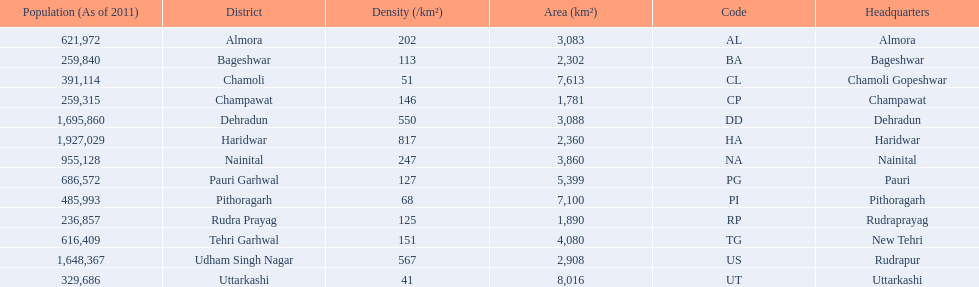What are all the districts? Almora, Bageshwar, Chamoli, Champawat, Dehradun, Haridwar, Nainital, Pauri Garhwal, Pithoragarh, Rudra Prayag, Tehri Garhwal, Udham Singh Nagar, Uttarkashi. And their densities? 202, 113, 51, 146, 550, 817, 247, 127, 68, 125, 151, 567, 41. Would you be able to parse every entry in this table? {'header': ['Population (As of 2011)', 'District', 'Density (/km²)', 'Area (km²)', 'Code', 'Headquarters'], 'rows': [['621,972', 'Almora', '202', '3,083', 'AL', 'Almora'], ['259,840', 'Bageshwar', '113', '2,302', 'BA', 'Bageshwar'], ['391,114', 'Chamoli', '51', '7,613', 'CL', 'Chamoli Gopeshwar'], ['259,315', 'Champawat', '146', '1,781', 'CP', 'Champawat'], ['1,695,860', 'Dehradun', '550', '3,088', 'DD', 'Dehradun'], ['1,927,029', 'Haridwar', '817', '2,360', 'HA', 'Haridwar'], ['955,128', 'Nainital', '247', '3,860', 'NA', 'Nainital'], ['686,572', 'Pauri Garhwal', '127', '5,399', 'PG', 'Pauri'], ['485,993', 'Pithoragarh', '68', '7,100', 'PI', 'Pithoragarh'], ['236,857', 'Rudra Prayag', '125', '1,890', 'RP', 'Rudraprayag'], ['616,409', 'Tehri Garhwal', '151', '4,080', 'TG', 'New Tehri'], ['1,648,367', 'Udham Singh Nagar', '567', '2,908', 'US', 'Rudrapur'], ['329,686', 'Uttarkashi', '41', '8,016', 'UT', 'Uttarkashi']]} Now, which district's density is 51? Chamoli. 